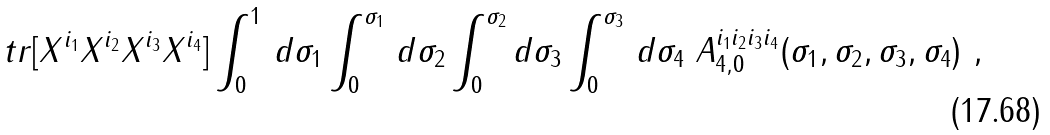Convert formula to latex. <formula><loc_0><loc_0><loc_500><loc_500>t r [ X ^ { i _ { 1 } } X ^ { i _ { 2 } } X ^ { i _ { 3 } } X ^ { i _ { 4 } } ] \int _ { 0 } ^ { 1 } \, d \sigma _ { 1 } \int _ { 0 } ^ { \sigma _ { 1 } } \, d \sigma _ { 2 } \int _ { 0 } ^ { \sigma _ { 2 } } d \sigma _ { 3 } \int _ { 0 } ^ { \sigma _ { 3 } } \, d \sigma _ { 4 } \ A _ { 4 , 0 } ^ { i _ { 1 } i _ { 2 } i _ { 3 } i _ { 4 } } ( \sigma _ { 1 } , \sigma _ { 2 } , \sigma _ { 3 } , \sigma _ { 4 } ) \ ,</formula> 